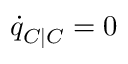Convert formula to latex. <formula><loc_0><loc_0><loc_500><loc_500>\dot { q } _ { C | C } = 0</formula> 